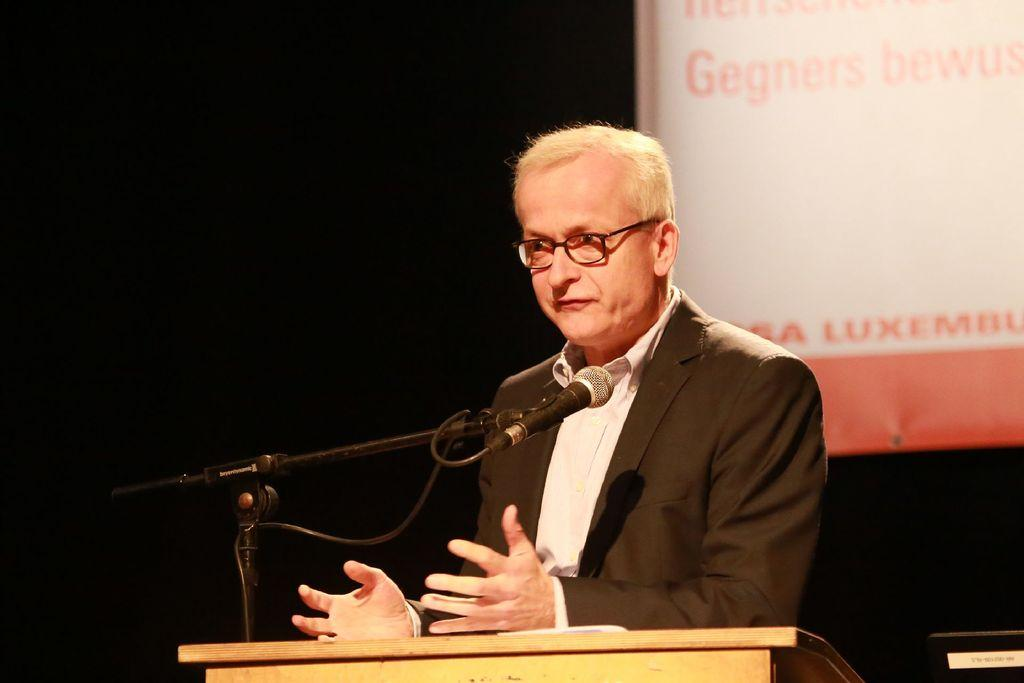Who is the main subject in the image? There is a man in the image. What is the man doing in the image? The man is standing near a podium and has his hands on it. What object is in front of the man? There is a microphone in front of the man. What can be seen in the background of the image? There is a banner in the background of the image. What type of discovery was made in the field, as mentioned on the banner in the image? There is no mention of a discovery or field on the banner in the image. 